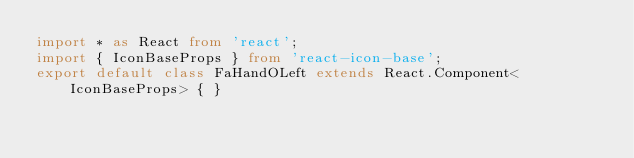<code> <loc_0><loc_0><loc_500><loc_500><_TypeScript_>import * as React from 'react';
import { IconBaseProps } from 'react-icon-base';
export default class FaHandOLeft extends React.Component<IconBaseProps> { }
</code> 